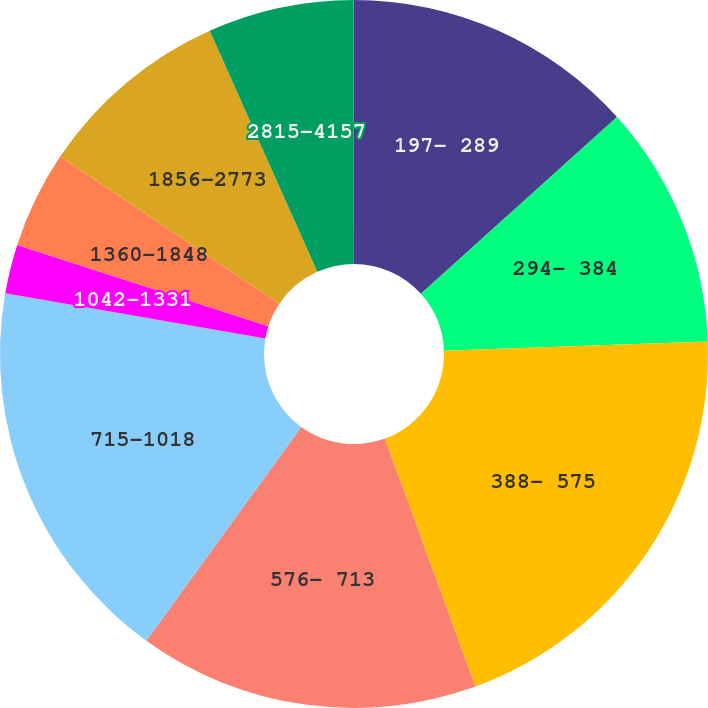Convert chart to OTSL. <chart><loc_0><loc_0><loc_500><loc_500><pie_chart><fcel>197- 289<fcel>294- 384<fcel>388- 575<fcel>576- 713<fcel>715-1018<fcel>1042-1331<fcel>1360-1848<fcel>1856-2773<fcel>2815-4157<fcel>4212-5527<nl><fcel>13.33%<fcel>11.11%<fcel>19.99%<fcel>15.55%<fcel>17.77%<fcel>2.23%<fcel>4.45%<fcel>8.89%<fcel>6.67%<fcel>0.01%<nl></chart> 